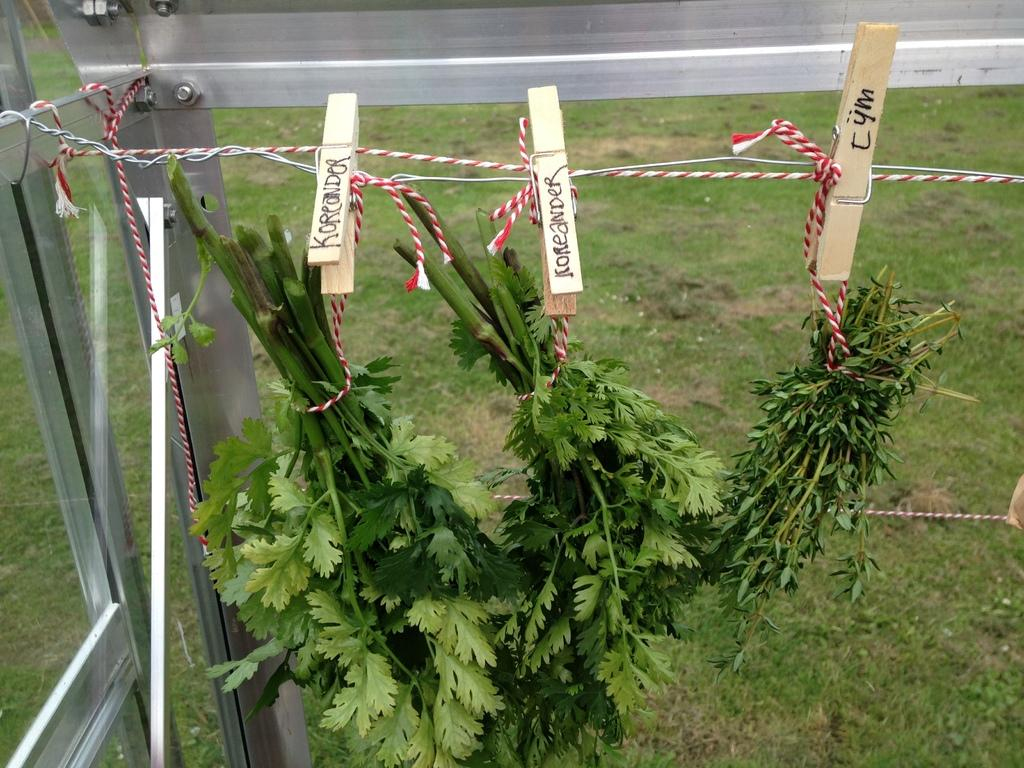<image>
Relay a brief, clear account of the picture shown. A few bundles of Tym are hanging from a clothesline. 